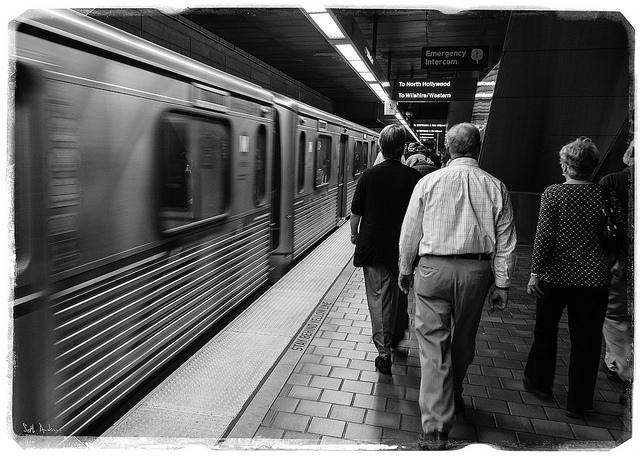Is the sidewalk paved?
Short answer required. Yes. Is this photo in color?
Concise answer only. No. Is anyone facing the camera?
Short answer required. No. 